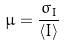<formula> <loc_0><loc_0><loc_500><loc_500>\mu = \frac { \sigma _ { I } } { \langle I \rangle }</formula> 